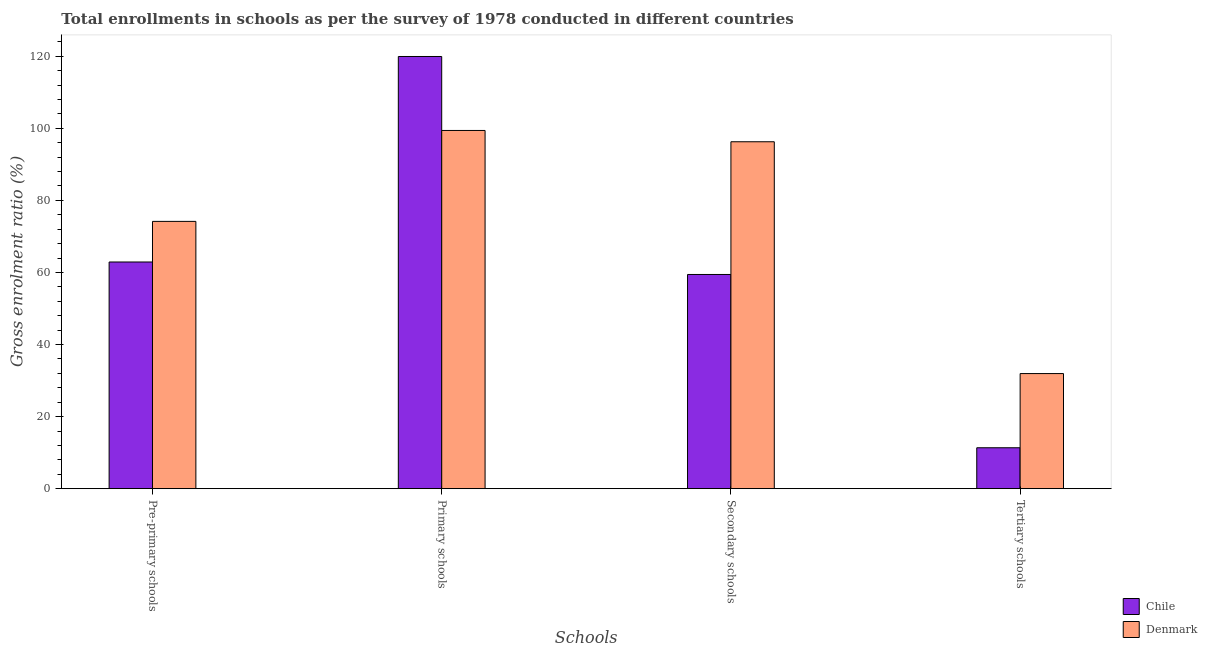How many different coloured bars are there?
Ensure brevity in your answer.  2. How many groups of bars are there?
Keep it short and to the point. 4. Are the number of bars per tick equal to the number of legend labels?
Make the answer very short. Yes. Are the number of bars on each tick of the X-axis equal?
Your response must be concise. Yes. How many bars are there on the 4th tick from the left?
Offer a terse response. 2. How many bars are there on the 1st tick from the right?
Keep it short and to the point. 2. What is the label of the 2nd group of bars from the left?
Give a very brief answer. Primary schools. What is the gross enrolment ratio in primary schools in Denmark?
Give a very brief answer. 99.4. Across all countries, what is the maximum gross enrolment ratio in pre-primary schools?
Offer a terse response. 74.17. Across all countries, what is the minimum gross enrolment ratio in tertiary schools?
Make the answer very short. 11.35. What is the total gross enrolment ratio in tertiary schools in the graph?
Keep it short and to the point. 43.3. What is the difference between the gross enrolment ratio in secondary schools in Denmark and that in Chile?
Offer a very short reply. 36.82. What is the difference between the gross enrolment ratio in pre-primary schools in Denmark and the gross enrolment ratio in secondary schools in Chile?
Offer a terse response. 14.73. What is the average gross enrolment ratio in secondary schools per country?
Ensure brevity in your answer.  77.85. What is the difference between the gross enrolment ratio in tertiary schools and gross enrolment ratio in pre-primary schools in Denmark?
Keep it short and to the point. -42.23. What is the ratio of the gross enrolment ratio in primary schools in Denmark to that in Chile?
Ensure brevity in your answer.  0.83. What is the difference between the highest and the second highest gross enrolment ratio in pre-primary schools?
Ensure brevity in your answer.  11.27. What is the difference between the highest and the lowest gross enrolment ratio in tertiary schools?
Make the answer very short. 20.59. In how many countries, is the gross enrolment ratio in pre-primary schools greater than the average gross enrolment ratio in pre-primary schools taken over all countries?
Keep it short and to the point. 1. Is the sum of the gross enrolment ratio in secondary schools in Denmark and Chile greater than the maximum gross enrolment ratio in tertiary schools across all countries?
Your response must be concise. Yes. Is it the case that in every country, the sum of the gross enrolment ratio in primary schools and gross enrolment ratio in secondary schools is greater than the sum of gross enrolment ratio in tertiary schools and gross enrolment ratio in pre-primary schools?
Offer a very short reply. No. How many bars are there?
Offer a very short reply. 8. What is the difference between two consecutive major ticks on the Y-axis?
Give a very brief answer. 20. Are the values on the major ticks of Y-axis written in scientific E-notation?
Your answer should be very brief. No. How are the legend labels stacked?
Offer a terse response. Vertical. What is the title of the graph?
Ensure brevity in your answer.  Total enrollments in schools as per the survey of 1978 conducted in different countries. What is the label or title of the X-axis?
Your answer should be very brief. Schools. What is the label or title of the Y-axis?
Provide a succinct answer. Gross enrolment ratio (%). What is the Gross enrolment ratio (%) in Chile in Pre-primary schools?
Provide a succinct answer. 62.9. What is the Gross enrolment ratio (%) in Denmark in Pre-primary schools?
Keep it short and to the point. 74.17. What is the Gross enrolment ratio (%) in Chile in Primary schools?
Your answer should be compact. 119.93. What is the Gross enrolment ratio (%) in Denmark in Primary schools?
Your response must be concise. 99.4. What is the Gross enrolment ratio (%) of Chile in Secondary schools?
Provide a succinct answer. 59.44. What is the Gross enrolment ratio (%) in Denmark in Secondary schools?
Your response must be concise. 96.26. What is the Gross enrolment ratio (%) in Chile in Tertiary schools?
Offer a very short reply. 11.35. What is the Gross enrolment ratio (%) of Denmark in Tertiary schools?
Your answer should be very brief. 31.94. Across all Schools, what is the maximum Gross enrolment ratio (%) in Chile?
Your answer should be very brief. 119.93. Across all Schools, what is the maximum Gross enrolment ratio (%) of Denmark?
Provide a succinct answer. 99.4. Across all Schools, what is the minimum Gross enrolment ratio (%) of Chile?
Offer a very short reply. 11.35. Across all Schools, what is the minimum Gross enrolment ratio (%) of Denmark?
Offer a very short reply. 31.94. What is the total Gross enrolment ratio (%) in Chile in the graph?
Offer a very short reply. 253.62. What is the total Gross enrolment ratio (%) of Denmark in the graph?
Make the answer very short. 301.78. What is the difference between the Gross enrolment ratio (%) in Chile in Pre-primary schools and that in Primary schools?
Offer a very short reply. -57.03. What is the difference between the Gross enrolment ratio (%) of Denmark in Pre-primary schools and that in Primary schools?
Offer a very short reply. -25.23. What is the difference between the Gross enrolment ratio (%) in Chile in Pre-primary schools and that in Secondary schools?
Give a very brief answer. 3.46. What is the difference between the Gross enrolment ratio (%) of Denmark in Pre-primary schools and that in Secondary schools?
Offer a terse response. -22.1. What is the difference between the Gross enrolment ratio (%) in Chile in Pre-primary schools and that in Tertiary schools?
Provide a short and direct response. 51.55. What is the difference between the Gross enrolment ratio (%) in Denmark in Pre-primary schools and that in Tertiary schools?
Your answer should be compact. 42.23. What is the difference between the Gross enrolment ratio (%) in Chile in Primary schools and that in Secondary schools?
Your answer should be very brief. 60.49. What is the difference between the Gross enrolment ratio (%) of Denmark in Primary schools and that in Secondary schools?
Keep it short and to the point. 3.14. What is the difference between the Gross enrolment ratio (%) in Chile in Primary schools and that in Tertiary schools?
Provide a short and direct response. 108.58. What is the difference between the Gross enrolment ratio (%) of Denmark in Primary schools and that in Tertiary schools?
Your response must be concise. 67.46. What is the difference between the Gross enrolment ratio (%) in Chile in Secondary schools and that in Tertiary schools?
Make the answer very short. 48.09. What is the difference between the Gross enrolment ratio (%) of Denmark in Secondary schools and that in Tertiary schools?
Ensure brevity in your answer.  64.32. What is the difference between the Gross enrolment ratio (%) in Chile in Pre-primary schools and the Gross enrolment ratio (%) in Denmark in Primary schools?
Provide a short and direct response. -36.5. What is the difference between the Gross enrolment ratio (%) of Chile in Pre-primary schools and the Gross enrolment ratio (%) of Denmark in Secondary schools?
Keep it short and to the point. -33.36. What is the difference between the Gross enrolment ratio (%) in Chile in Pre-primary schools and the Gross enrolment ratio (%) in Denmark in Tertiary schools?
Ensure brevity in your answer.  30.96. What is the difference between the Gross enrolment ratio (%) in Chile in Primary schools and the Gross enrolment ratio (%) in Denmark in Secondary schools?
Make the answer very short. 23.66. What is the difference between the Gross enrolment ratio (%) in Chile in Primary schools and the Gross enrolment ratio (%) in Denmark in Tertiary schools?
Your response must be concise. 87.99. What is the difference between the Gross enrolment ratio (%) of Chile in Secondary schools and the Gross enrolment ratio (%) of Denmark in Tertiary schools?
Provide a succinct answer. 27.5. What is the average Gross enrolment ratio (%) in Chile per Schools?
Give a very brief answer. 63.41. What is the average Gross enrolment ratio (%) in Denmark per Schools?
Offer a very short reply. 75.44. What is the difference between the Gross enrolment ratio (%) in Chile and Gross enrolment ratio (%) in Denmark in Pre-primary schools?
Your answer should be very brief. -11.27. What is the difference between the Gross enrolment ratio (%) of Chile and Gross enrolment ratio (%) of Denmark in Primary schools?
Your response must be concise. 20.53. What is the difference between the Gross enrolment ratio (%) in Chile and Gross enrolment ratio (%) in Denmark in Secondary schools?
Your answer should be compact. -36.82. What is the difference between the Gross enrolment ratio (%) of Chile and Gross enrolment ratio (%) of Denmark in Tertiary schools?
Make the answer very short. -20.59. What is the ratio of the Gross enrolment ratio (%) of Chile in Pre-primary schools to that in Primary schools?
Give a very brief answer. 0.52. What is the ratio of the Gross enrolment ratio (%) of Denmark in Pre-primary schools to that in Primary schools?
Provide a short and direct response. 0.75. What is the ratio of the Gross enrolment ratio (%) in Chile in Pre-primary schools to that in Secondary schools?
Offer a very short reply. 1.06. What is the ratio of the Gross enrolment ratio (%) of Denmark in Pre-primary schools to that in Secondary schools?
Provide a short and direct response. 0.77. What is the ratio of the Gross enrolment ratio (%) in Chile in Pre-primary schools to that in Tertiary schools?
Make the answer very short. 5.54. What is the ratio of the Gross enrolment ratio (%) in Denmark in Pre-primary schools to that in Tertiary schools?
Ensure brevity in your answer.  2.32. What is the ratio of the Gross enrolment ratio (%) of Chile in Primary schools to that in Secondary schools?
Your answer should be very brief. 2.02. What is the ratio of the Gross enrolment ratio (%) of Denmark in Primary schools to that in Secondary schools?
Your answer should be compact. 1.03. What is the ratio of the Gross enrolment ratio (%) in Chile in Primary schools to that in Tertiary schools?
Your answer should be compact. 10.56. What is the ratio of the Gross enrolment ratio (%) of Denmark in Primary schools to that in Tertiary schools?
Your answer should be compact. 3.11. What is the ratio of the Gross enrolment ratio (%) of Chile in Secondary schools to that in Tertiary schools?
Ensure brevity in your answer.  5.24. What is the ratio of the Gross enrolment ratio (%) in Denmark in Secondary schools to that in Tertiary schools?
Provide a succinct answer. 3.01. What is the difference between the highest and the second highest Gross enrolment ratio (%) in Chile?
Keep it short and to the point. 57.03. What is the difference between the highest and the second highest Gross enrolment ratio (%) in Denmark?
Offer a terse response. 3.14. What is the difference between the highest and the lowest Gross enrolment ratio (%) of Chile?
Make the answer very short. 108.58. What is the difference between the highest and the lowest Gross enrolment ratio (%) of Denmark?
Ensure brevity in your answer.  67.46. 